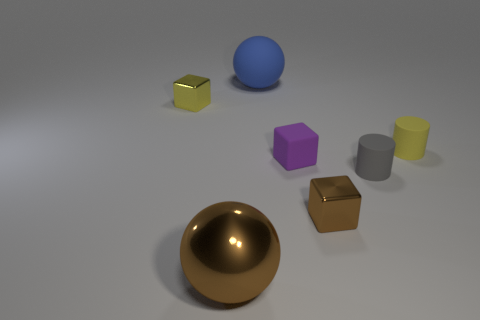Subtract all blocks. How many objects are left? 4 Subtract 2 cylinders. How many cylinders are left? 0 Subtract all purple balls. Subtract all brown blocks. How many balls are left? 2 Subtract all blue spheres. How many purple cubes are left? 1 Subtract all large brown shiny spheres. Subtract all small matte cubes. How many objects are left? 5 Add 7 brown shiny objects. How many brown shiny objects are left? 9 Add 1 small red balls. How many small red balls exist? 1 Add 2 gray cylinders. How many objects exist? 9 Subtract all gray cylinders. How many cylinders are left? 1 Subtract all matte blocks. How many blocks are left? 2 